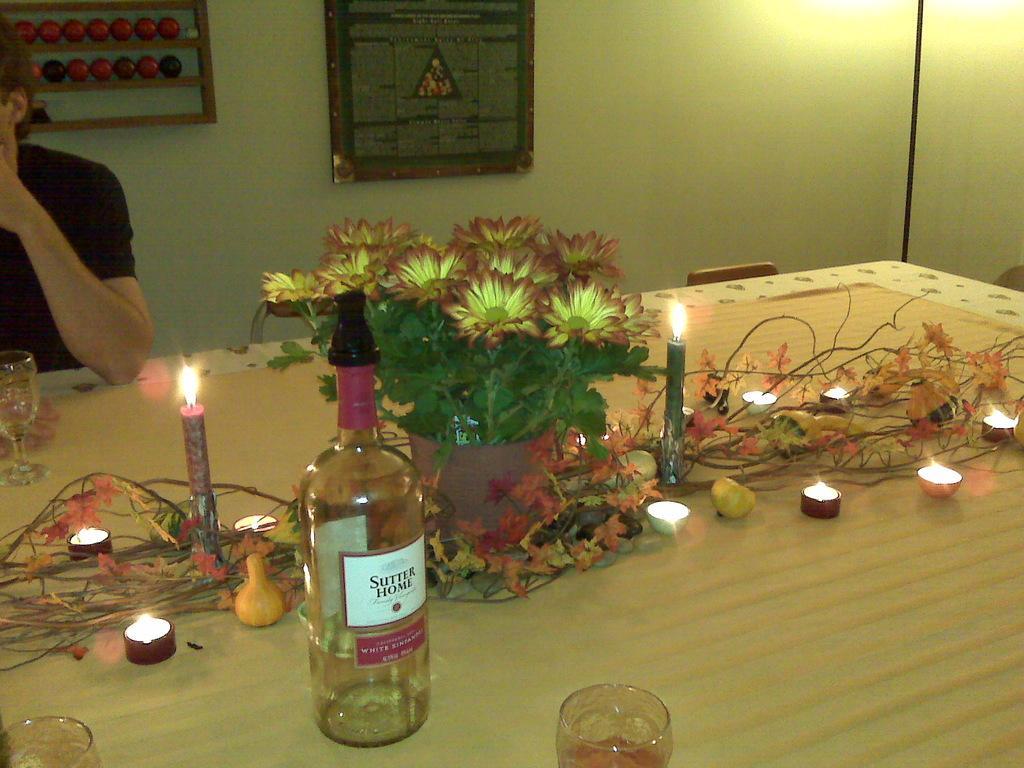Can you describe this image briefly? In this picture we can see a table. On the table there is a bottle, glass, candles, and a flower vase. Here we can see a person. On the background there is a wall and this is frame. 